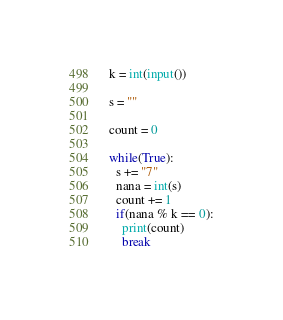Convert code to text. <code><loc_0><loc_0><loc_500><loc_500><_Python_>k = int(input())

s = ""

count = 0

while(True):
  s += "7"
  nana = int(s)
  count += 1
  if(nana % k == 0):
    print(count)
    break</code> 